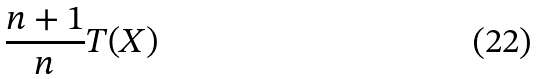Convert formula to latex. <formula><loc_0><loc_0><loc_500><loc_500>\frac { n + 1 } { n } T ( X )</formula> 